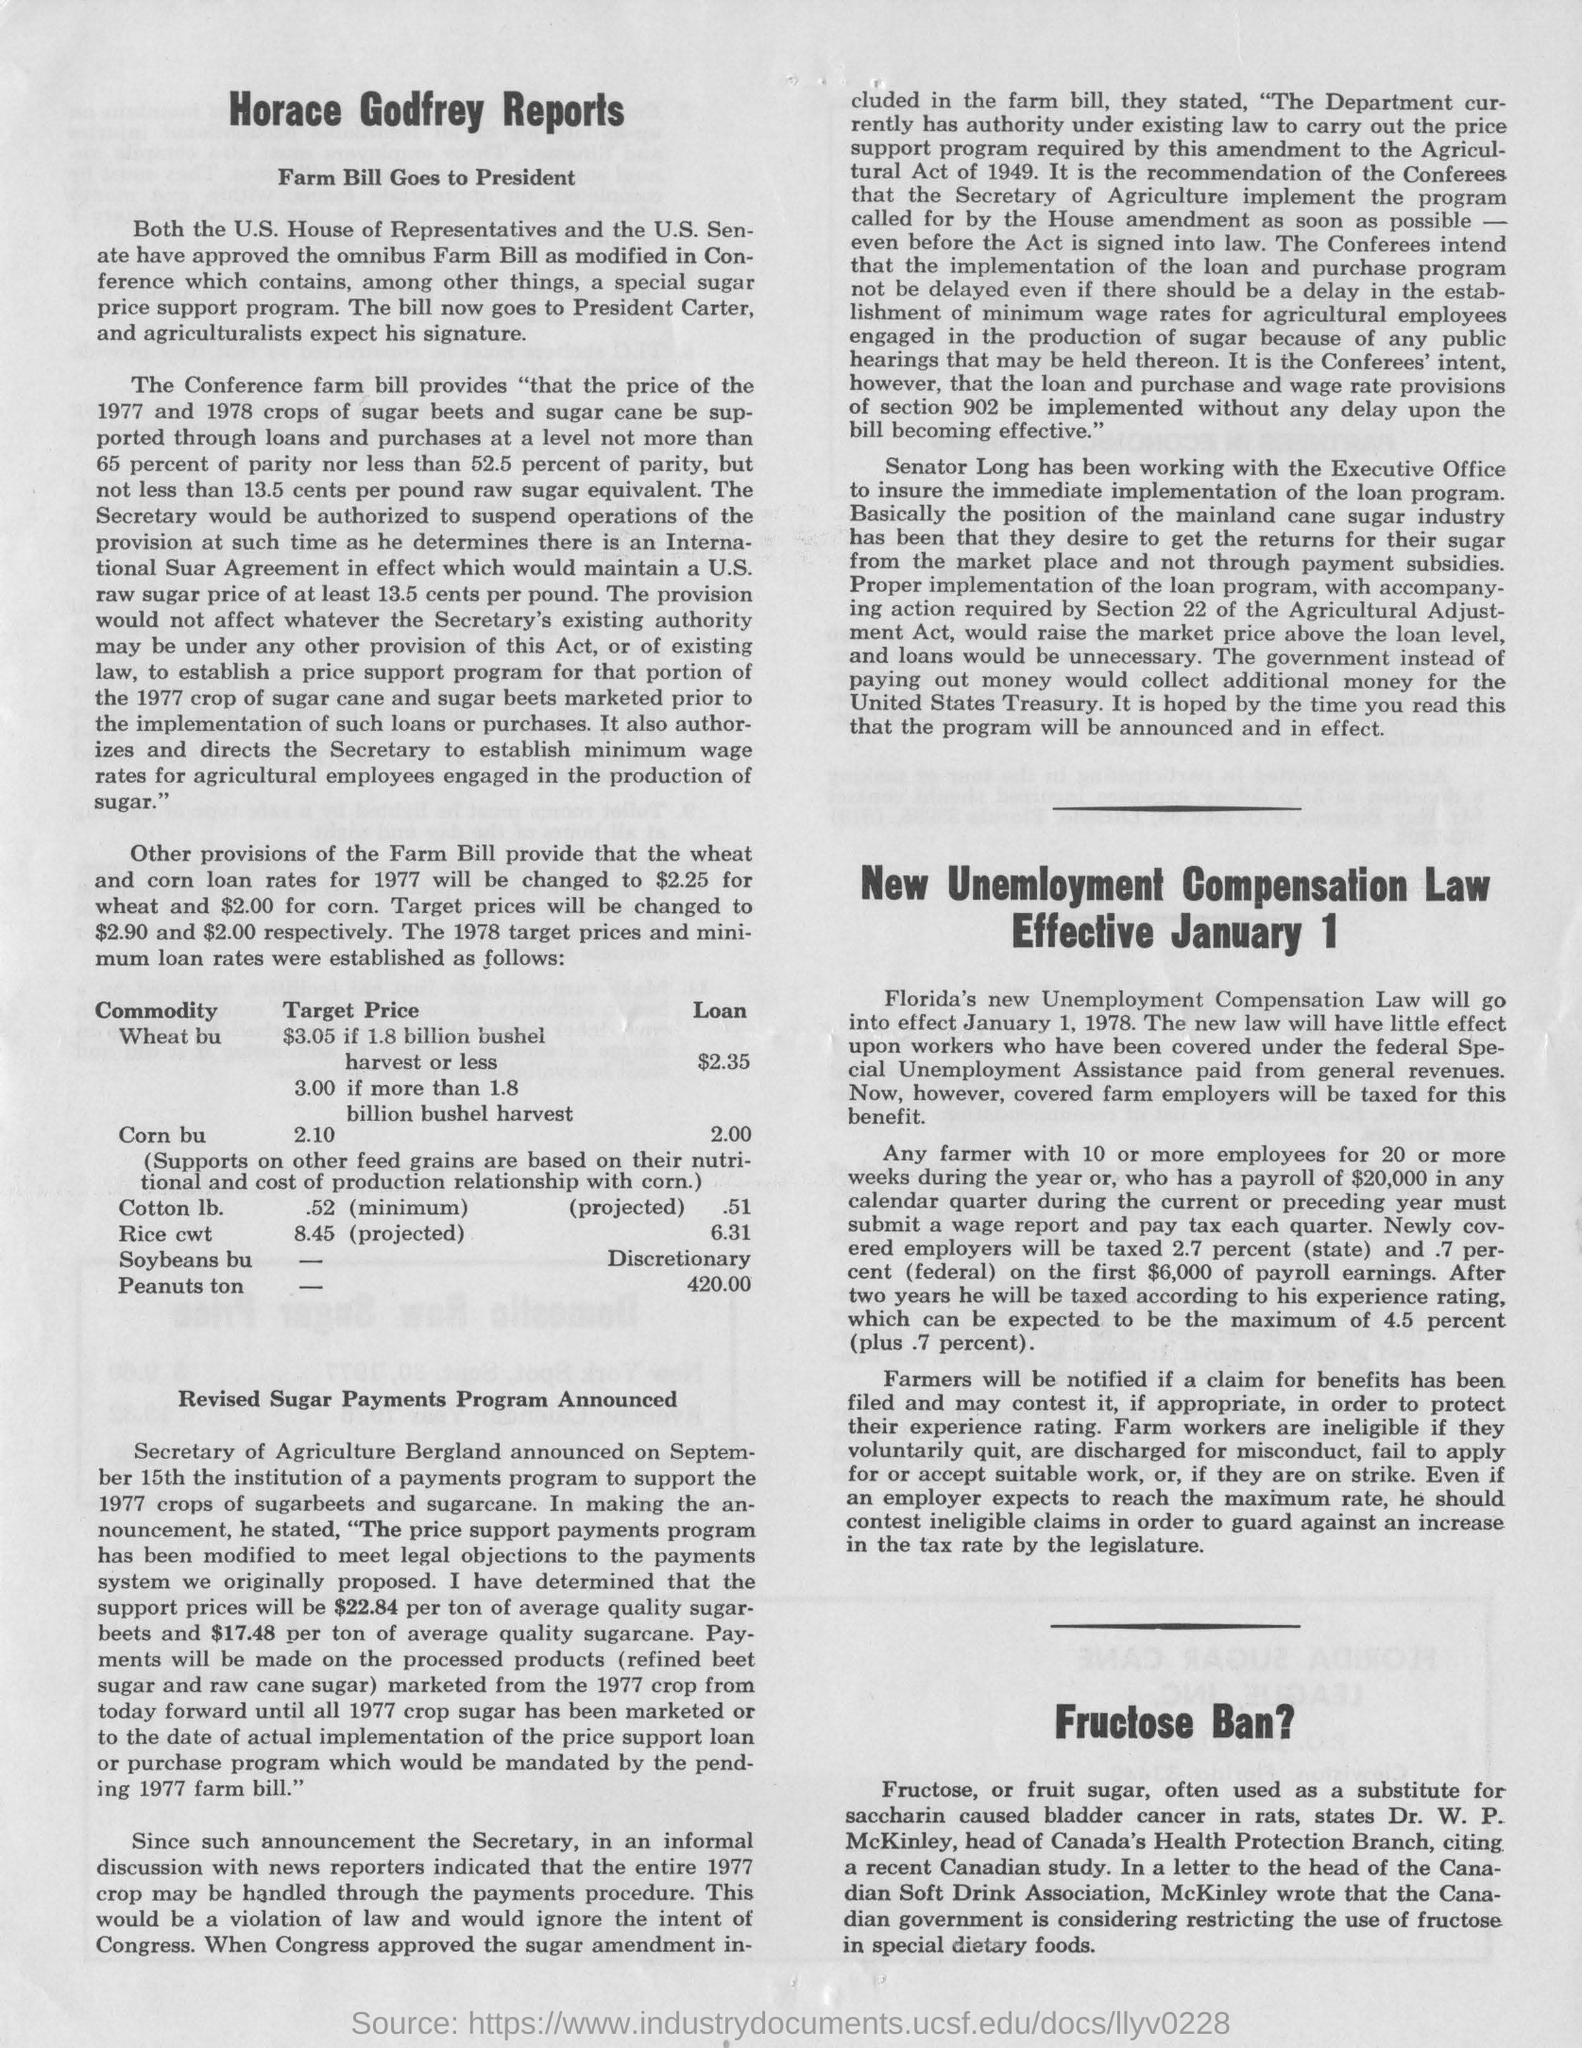Who is the head of Canada's Health Protection Branch?
Ensure brevity in your answer.  Dr. W. P. McKinley. What is fructose often used as a substitute for?
Your answer should be compact. Saccharin. 